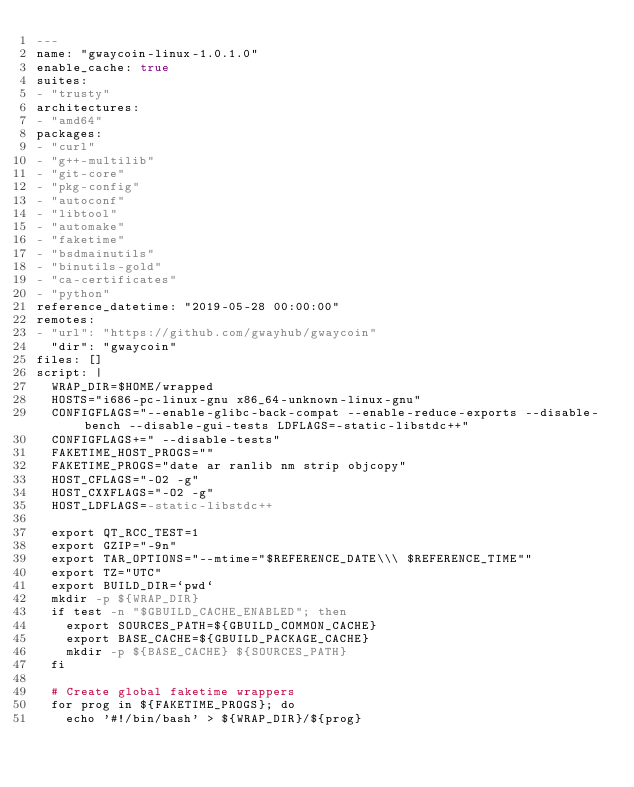<code> <loc_0><loc_0><loc_500><loc_500><_YAML_>---
name: "gwaycoin-linux-1.0.1.0"
enable_cache: true
suites:
- "trusty"
architectures:
- "amd64"
packages:
- "curl"
- "g++-multilib"
- "git-core"
- "pkg-config"
- "autoconf"
- "libtool"
- "automake"
- "faketime"
- "bsdmainutils"
- "binutils-gold"
- "ca-certificates"
- "python"
reference_datetime: "2019-05-28 00:00:00"
remotes:
- "url": "https://github.com/gwayhub/gwaycoin"
  "dir": "gwaycoin"
files: []
script: |
  WRAP_DIR=$HOME/wrapped
  HOSTS="i686-pc-linux-gnu x86_64-unknown-linux-gnu"
  CONFIGFLAGS="--enable-glibc-back-compat --enable-reduce-exports --disable-bench --disable-gui-tests LDFLAGS=-static-libstdc++"
  CONFIGFLAGS+=" --disable-tests"
  FAKETIME_HOST_PROGS=""
  FAKETIME_PROGS="date ar ranlib nm strip objcopy"
  HOST_CFLAGS="-O2 -g"
  HOST_CXXFLAGS="-O2 -g"
  HOST_LDFLAGS=-static-libstdc++

  export QT_RCC_TEST=1
  export GZIP="-9n"
  export TAR_OPTIONS="--mtime="$REFERENCE_DATE\\\ $REFERENCE_TIME""
  export TZ="UTC"
  export BUILD_DIR=`pwd`
  mkdir -p ${WRAP_DIR}
  if test -n "$GBUILD_CACHE_ENABLED"; then
    export SOURCES_PATH=${GBUILD_COMMON_CACHE}
    export BASE_CACHE=${GBUILD_PACKAGE_CACHE}
    mkdir -p ${BASE_CACHE} ${SOURCES_PATH}
  fi

  # Create global faketime wrappers
  for prog in ${FAKETIME_PROGS}; do
    echo '#!/bin/bash' > ${WRAP_DIR}/${prog}</code> 